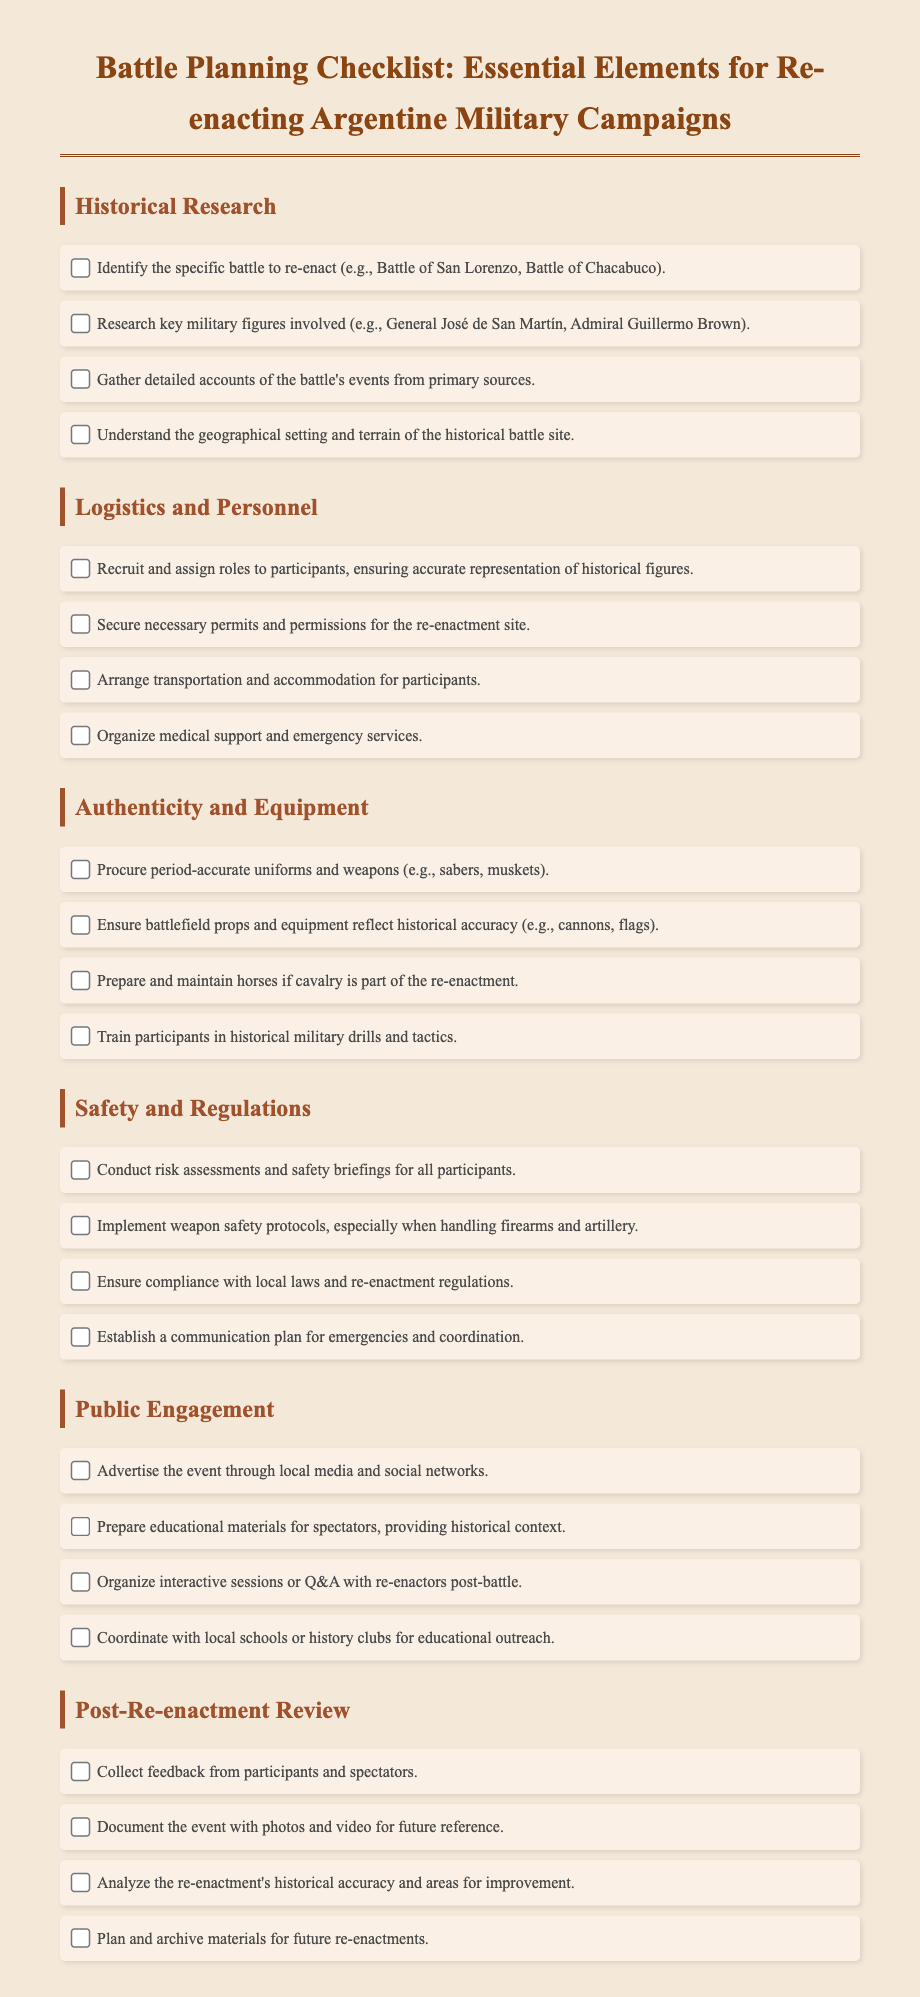What is the title of the document? The title of the document is located at the top of the rendered page.
Answer: Battle Planning Checklist: Essential Elements for Re-enacting Argentine Military Campaigns Which battle is mentioned as an example in the checklist? The example battle is listed under the Historical Research section as a specific battle to re-enact.
Answer: Battle of San Lorenzo How many sections are there in the document? The sections are organized and listed separately in the document.
Answer: Six Who is a key military figure involved in the campaigns? This name is found in the Historical Research section under key military figures.
Answer: General José de San Martín What should be organized for the safety of participants? This requirement is emphasized in the Safety and Regulations section.
Answer: Medical support and emergency services What type of event engagement is suggested for spectators? This suggestion is found in the Public Engagement section of the checklist.
Answer: Interactive sessions or Q&A with re-enactors post-battle In which checklist section is the historical accuracy of the re-enactment analyzed? This information is found in the Post-Re-enactment Review section.
Answer: Post-Re-enactment Review What items need to be procured for authenticity? This item is specified in the Authenticity and Equipment section of the checklist.
Answer: Period-accurate uniforms and weapons 